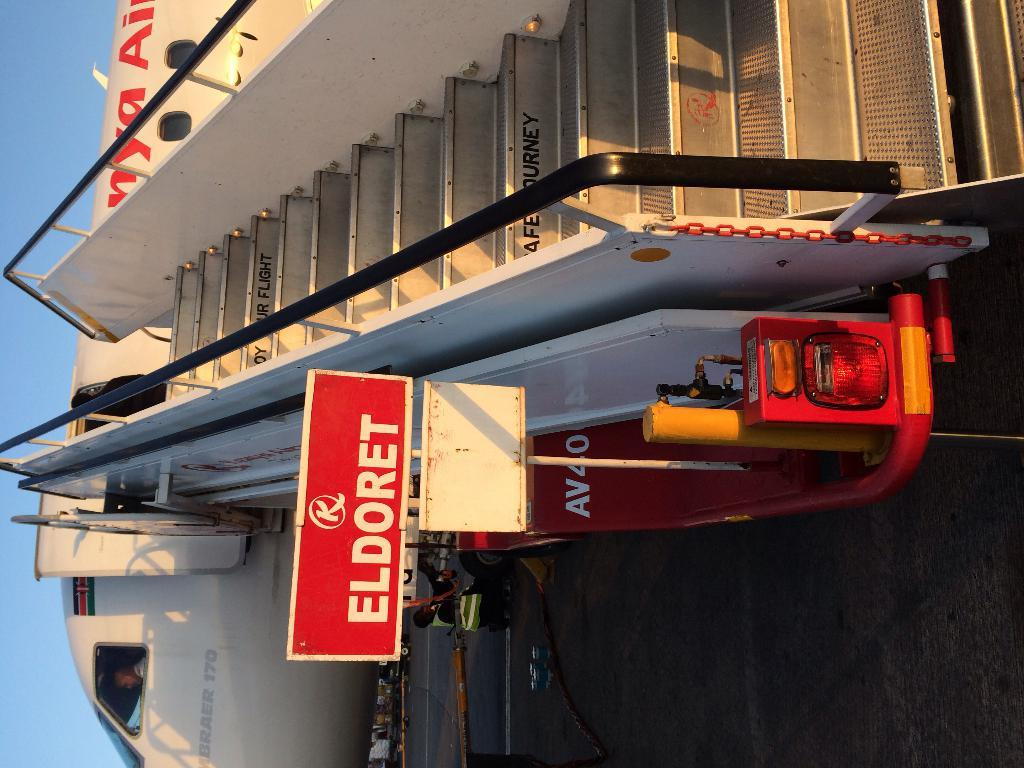<image>
Provide a brief description of the given image. Red Eldoret sign next to some airplane steps. 